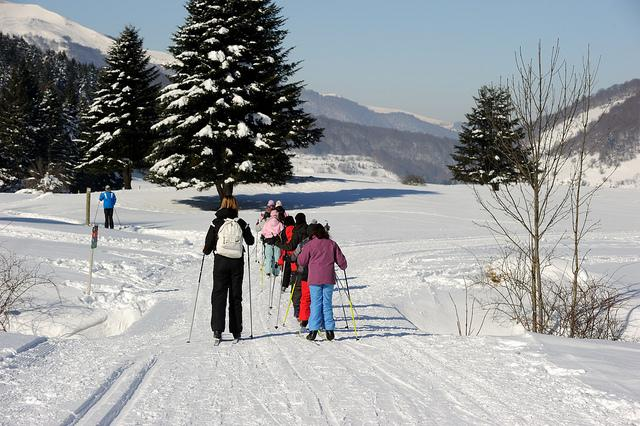What kind of terrain is best for this activity? Please explain your reasoning. flat. The terrain is flat. 